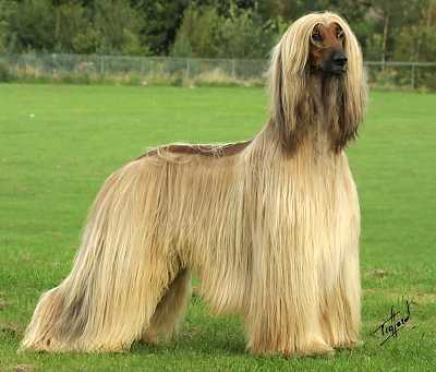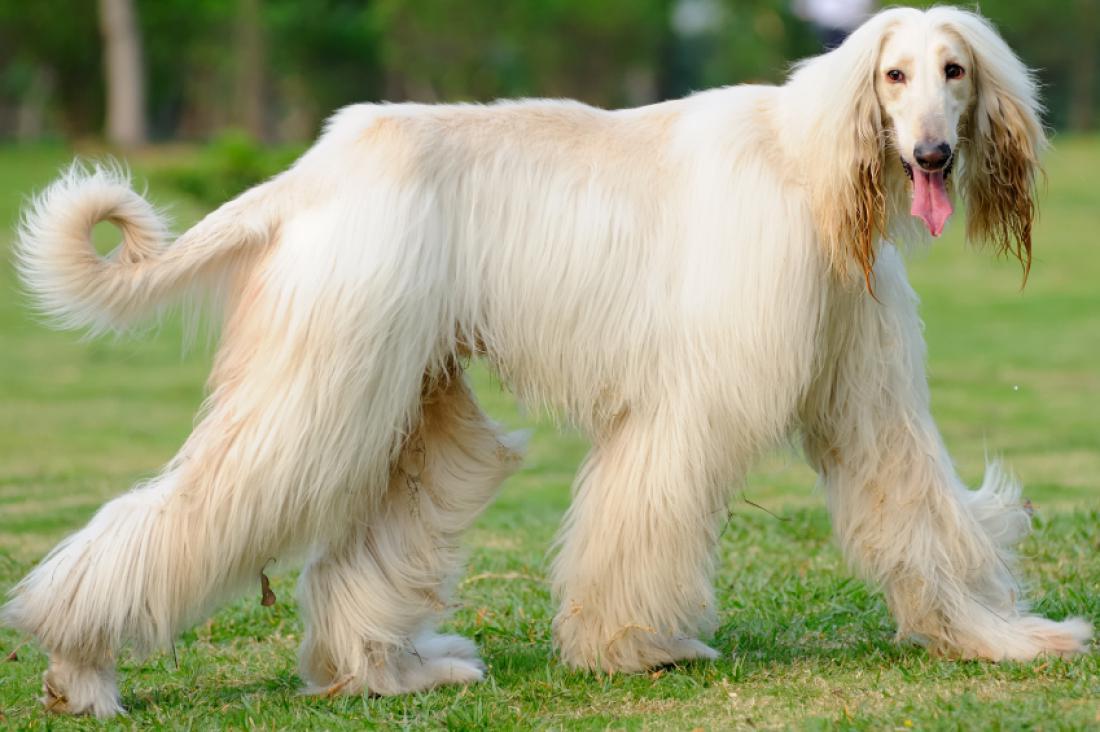The first image is the image on the left, the second image is the image on the right. For the images displayed, is the sentence "The bodies of the dogs in the paired images are turned in the same direction." factually correct? Answer yes or no. Yes. 